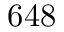Convert formula to latex. <formula><loc_0><loc_0><loc_500><loc_500>6 4 8</formula> 